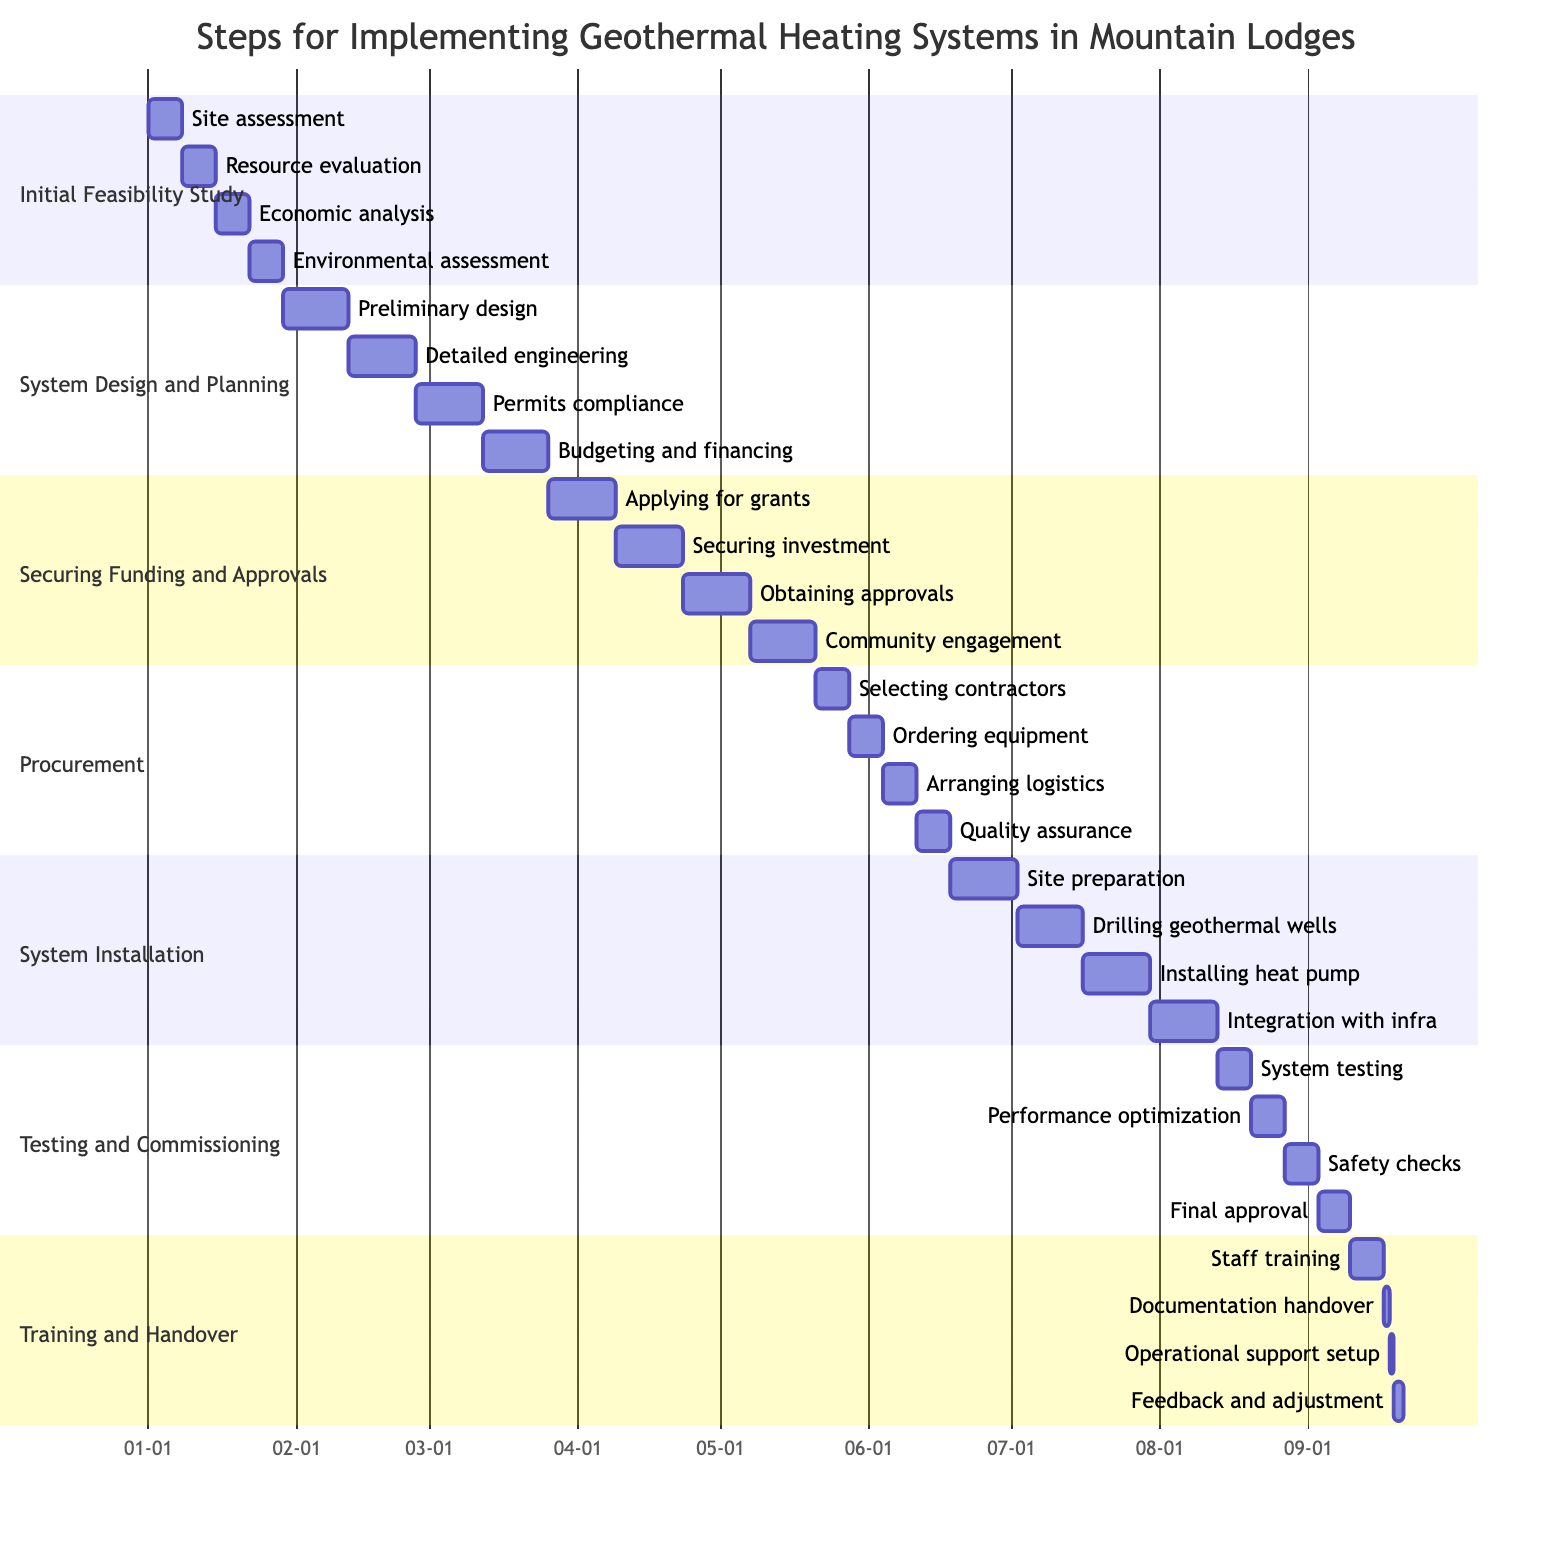What is the total duration of the "System Design and Planning" phase? The "System Design and Planning" phase consists of four tasks: Preliminary design (2 weeks), Detailed engineering (2 weeks), Permits compliance (2 weeks), and Budgeting and financing (2 weeks). Adding these durations together gives a total of 8 weeks.
Answer: 8 weeks Which tasks are included in the "Initial Feasibility Study"? The tasks in the "Initial Feasibility Study" are: Site assessment, Resource evaluation, Economic feasibility analysis, and Environmental impact assessment.
Answer: 4 tasks What is the duration of the "Testing and Commissioning" phase? The "Testing and Commissioning" phase includes four tasks: System testing (1 week), Performance optimization (1 week), Safety checks (1 week), and Final approval (1 week). The total duration sums to 4 weeks.
Answer: 4 weeks How many weeks does it take to complete the "Securing Funding and Approvals" section? The "Securing Funding and Approvals" section consists of four tasks, each lasting 2 weeks: Applying for grants, Securing investment, Obtaining approvals, and Community engagement. Thus, the total is 8 weeks.
Answer: 8 weeks What comes after "Community engagement" in the project timeline? After "Community engagement," the next task is "Selecting contractors and suppliers" in the "Procurement of Materials and Services" section.
Answer: Selecting contractors and suppliers What is the relationship between "Drilling geothermal wells" and "System testing"? "Drilling geothermal wells" is part of the "System Installation" section and occurs before "System testing," which is in the "Testing and Commissioning" section. This indicates a sequential relationship where installation precedes testing.
Answer: Sequential relationship Which task is the last in the "Training and Handover" section? The last task in the "Training and Handover" section is "Feedback collection and adjustment," which is the fourth task.
Answer: Feedback collection and adjustment What is the total number of tasks in the "System Installation" section? The "System Installation" section contains four tasks: Site preparation, Drilling geothermal wells, Installing heat pump, and Integration with existing infrastructure.
Answer: 4 tasks What is the duration of "Staff training" in the "Training and Handover" section? "Staff training" in the "Training and Handover" section has a duration of 1 week.
Answer: 1 week 